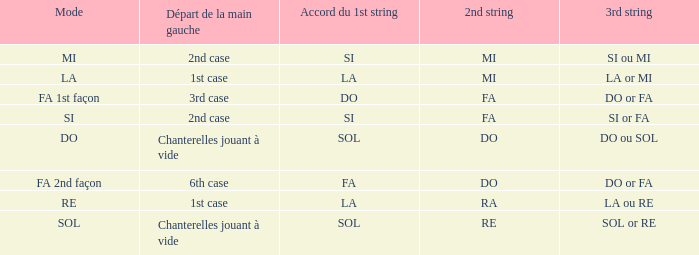For the 2nd string of Do and an Accord du 1st string of FA what is the Depart de la main gauche? 6th case. 